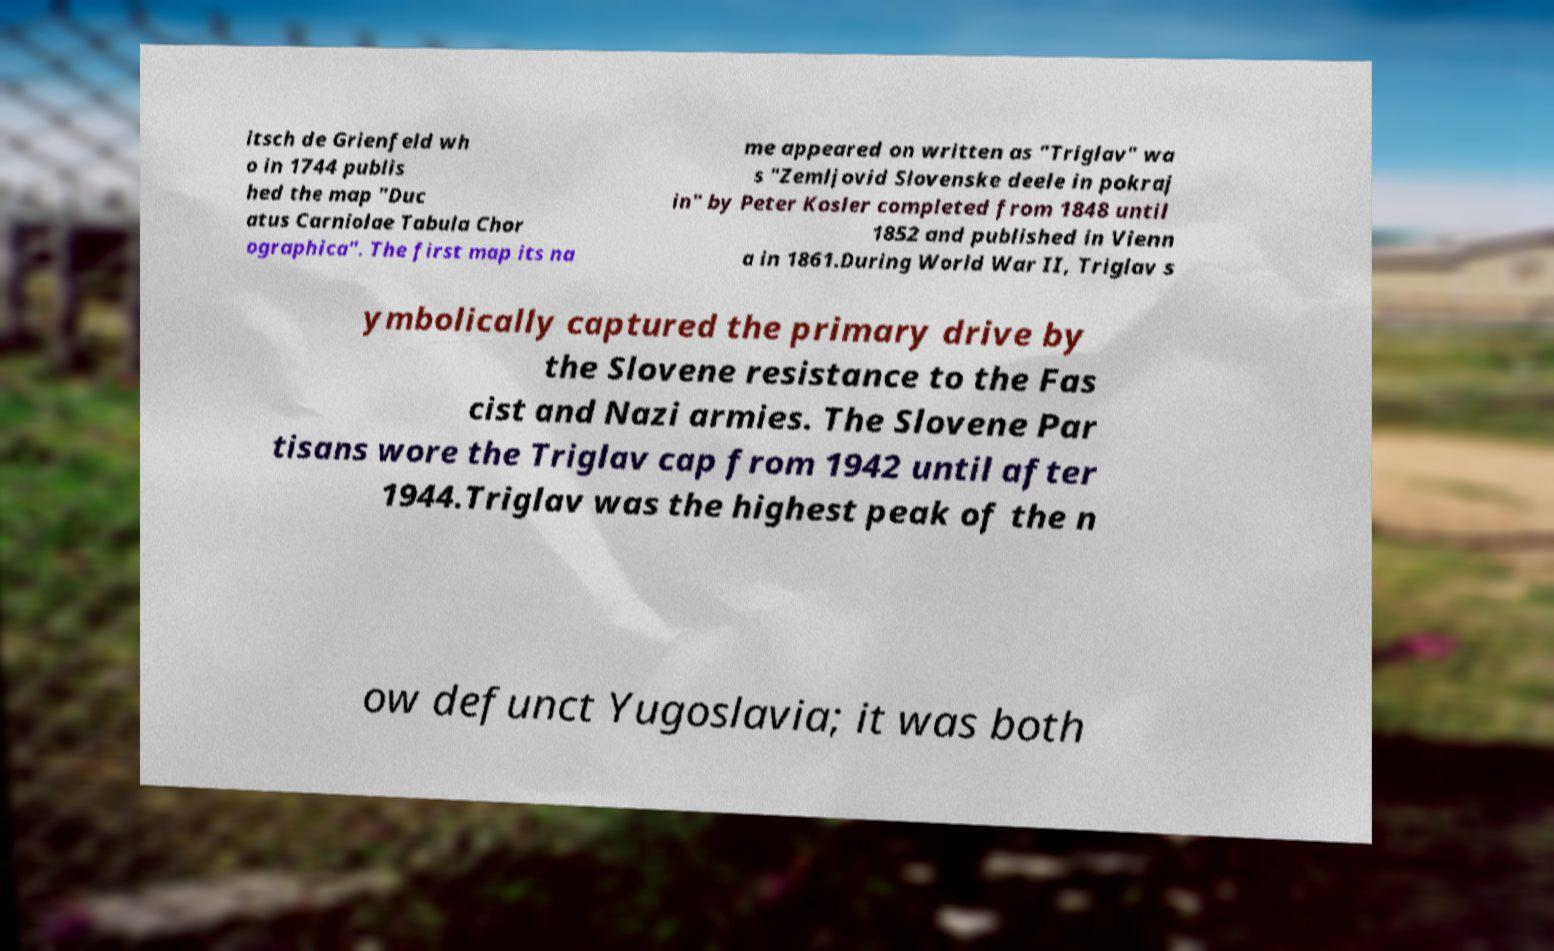I need the written content from this picture converted into text. Can you do that? itsch de Grienfeld wh o in 1744 publis hed the map "Duc atus Carniolae Tabula Chor ographica". The first map its na me appeared on written as "Triglav" wa s "Zemljovid Slovenske deele in pokraj in" by Peter Kosler completed from 1848 until 1852 and published in Vienn a in 1861.During World War II, Triglav s ymbolically captured the primary drive by the Slovene resistance to the Fas cist and Nazi armies. The Slovene Par tisans wore the Triglav cap from 1942 until after 1944.Triglav was the highest peak of the n ow defunct Yugoslavia; it was both 